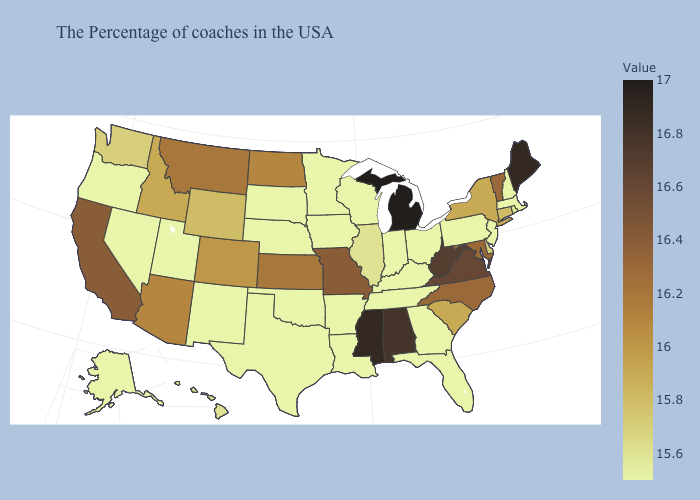Does the map have missing data?
Short answer required. No. Does Pennsylvania have a lower value than South Carolina?
Write a very short answer. Yes. Is the legend a continuous bar?
Keep it brief. Yes. Which states hav the highest value in the South?
Give a very brief answer. Mississippi. Does Montana have the highest value in the USA?
Short answer required. No. 